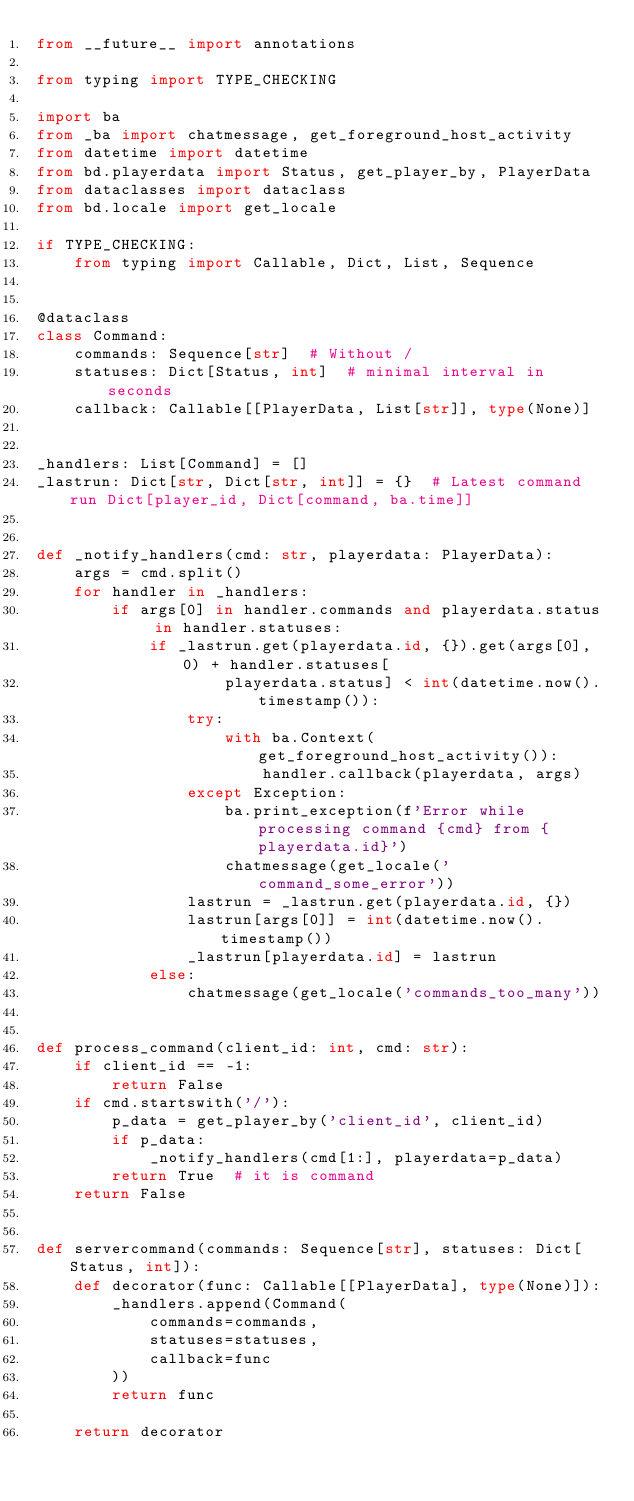Convert code to text. <code><loc_0><loc_0><loc_500><loc_500><_Python_>from __future__ import annotations

from typing import TYPE_CHECKING

import ba
from _ba import chatmessage, get_foreground_host_activity
from datetime import datetime
from bd.playerdata import Status, get_player_by, PlayerData
from dataclasses import dataclass
from bd.locale import get_locale

if TYPE_CHECKING:
    from typing import Callable, Dict, List, Sequence


@dataclass
class Command:
    commands: Sequence[str]  # Without /
    statuses: Dict[Status, int]  # minimal interval in seconds
    callback: Callable[[PlayerData, List[str]], type(None)]


_handlers: List[Command] = []
_lastrun: Dict[str, Dict[str, int]] = {}  # Latest command run Dict[player_id, Dict[command, ba.time]]


def _notify_handlers(cmd: str, playerdata: PlayerData):
    args = cmd.split()
    for handler in _handlers:
        if args[0] in handler.commands and playerdata.status in handler.statuses:
            if _lastrun.get(playerdata.id, {}).get(args[0], 0) + handler.statuses[
                    playerdata.status] < int(datetime.now().timestamp()):
                try:
                    with ba.Context(get_foreground_host_activity()):
                        handler.callback(playerdata, args)
                except Exception:
                    ba.print_exception(f'Error while processing command {cmd} from {playerdata.id}')
                    chatmessage(get_locale('command_some_error'))
                lastrun = _lastrun.get(playerdata.id, {})
                lastrun[args[0]] = int(datetime.now().timestamp())
                _lastrun[playerdata.id] = lastrun
            else:
                chatmessage(get_locale('commands_too_many'))


def process_command(client_id: int, cmd: str):
    if client_id == -1:
        return False
    if cmd.startswith('/'):
        p_data = get_player_by('client_id', client_id)
        if p_data:
            _notify_handlers(cmd[1:], playerdata=p_data)
        return True  # it is command
    return False


def servercommand(commands: Sequence[str], statuses: Dict[Status, int]):
    def decorator(func: Callable[[PlayerData], type(None)]):
        _handlers.append(Command(
            commands=commands,
            statuses=statuses,
            callback=func
        ))
        return func

    return decorator
</code> 